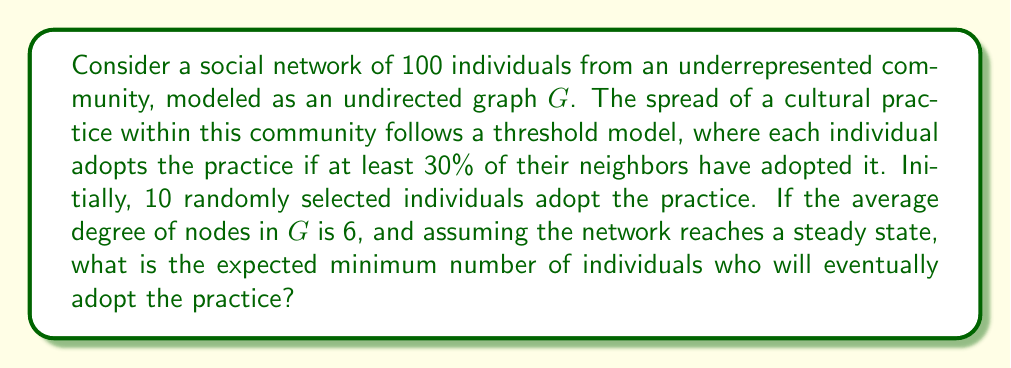Provide a solution to this math problem. To solve this problem, we need to consider the diffusion process on the graph and analyze its progression:

1) Initial state:
   - Total nodes: $n = 100$
   - Initially adopted: $a_0 = 10$
   - Threshold: $t = 30\% = 0.3$
   - Average degree: $d_{avg} = 6$

2) Threshold condition:
   For a node to adopt, it needs at least $0.3 \times 6 = 1.8$, or 2 adopting neighbors (rounding up).

3) Expected spread:
   Let's consider the probability of a non-adopting node having at least 2 adopting neighbors:
   
   $$P(\text{adopt}) = 1 - P(\text{0 adopting neighbors}) - P(\text{1 adopting neighbor})$$

   $$P(\text{adopt}) = 1 - \binom{6}{0}\left(\frac{a}{n}\right)^0\left(1-\frac{a}{n}\right)^6 - \binom{6}{1}\left(\frac{a}{n}\right)^1\left(1-\frac{a}{n}\right)^5$$

   Where $a$ is the current number of adopters and $n$ is the total population.

4) Iterative process:
   Starting with $a_0 = 10$, we can iteratively calculate the expected number of new adopters in each round:

   Round 1: $a_1 = 10 + 90 \times P(\text{adopt})_{a=10}$
   Round 2: $a_2 = a_1 + (100 - a_1) \times P(\text{adopt})_{a=a_1}$
   And so on, until the process converges.

5) Convergence:
   The process converges when the number of new adopters becomes negligible (e.g., less than 1).

6) Calculation:
   Using a computational tool to perform these iterations, we find that the process converges to approximately 51 adopters.
Answer: The expected minimum number of individuals who will eventually adopt the practice is approximately 51. 